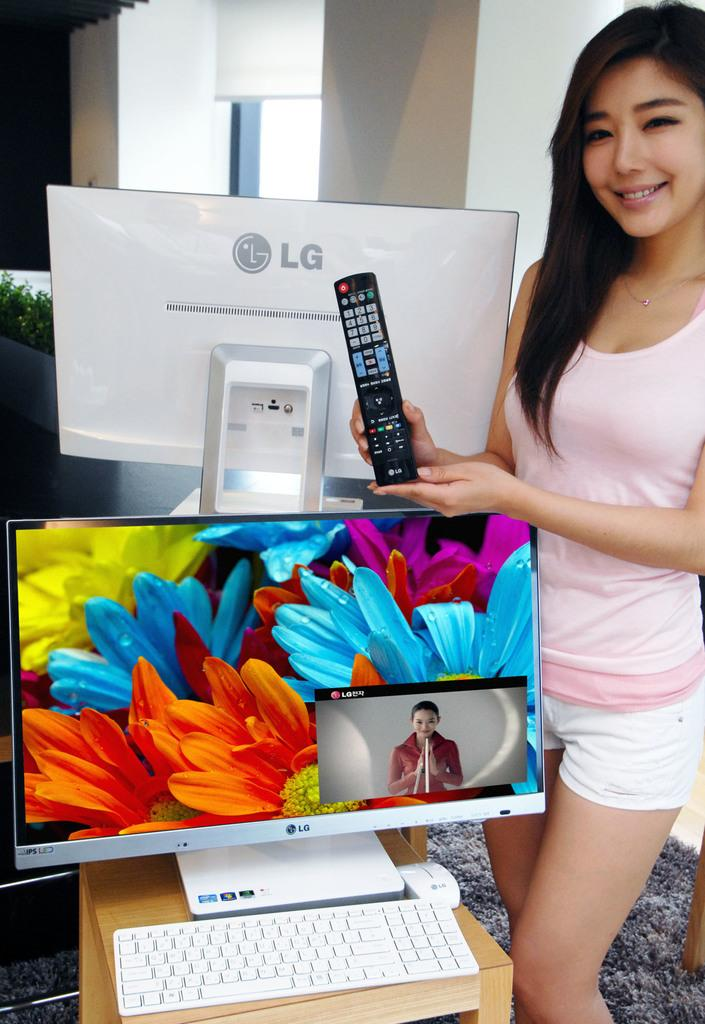<image>
Summarize the visual content of the image. A girl showcasing an LG remote and standing beside an LG computer. 